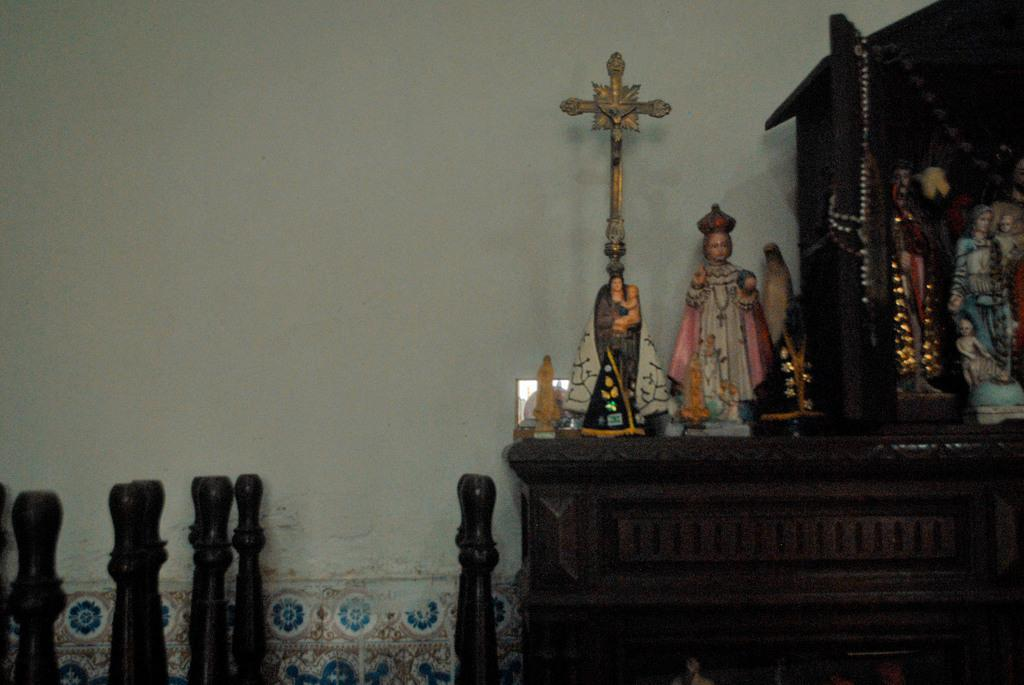What is on the desk in the image? There are idols and a cross on the desk. Are there any other objects on the desk besides the idols and cross? Yes, there are other objects on the desk. What can be seen on the left side of the image? There are wooden objects on the left side of the image. What color is the wall in the image? The wall in the image is painted white. Where is the stove located in the image? There is no stove present in the image. What type of crate can be seen on the desk? There is no crate present in the image. 